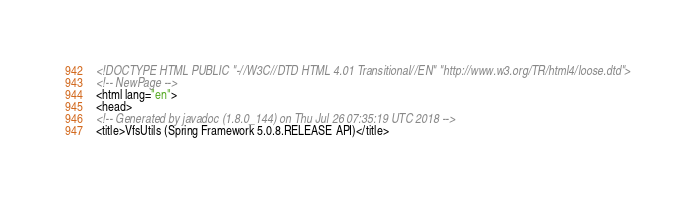<code> <loc_0><loc_0><loc_500><loc_500><_HTML_><!DOCTYPE HTML PUBLIC "-//W3C//DTD HTML 4.01 Transitional//EN" "http://www.w3.org/TR/html4/loose.dtd">
<!-- NewPage -->
<html lang="en">
<head>
<!-- Generated by javadoc (1.8.0_144) on Thu Jul 26 07:35:19 UTC 2018 -->
<title>VfsUtils (Spring Framework 5.0.8.RELEASE API)</title></code> 